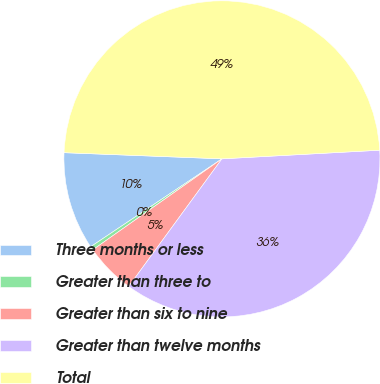Convert chart to OTSL. <chart><loc_0><loc_0><loc_500><loc_500><pie_chart><fcel>Three months or less<fcel>Greater than three to<fcel>Greater than six to nine<fcel>Greater than twelve months<fcel>Total<nl><fcel>10.01%<fcel>0.38%<fcel>5.19%<fcel>35.91%<fcel>48.51%<nl></chart> 